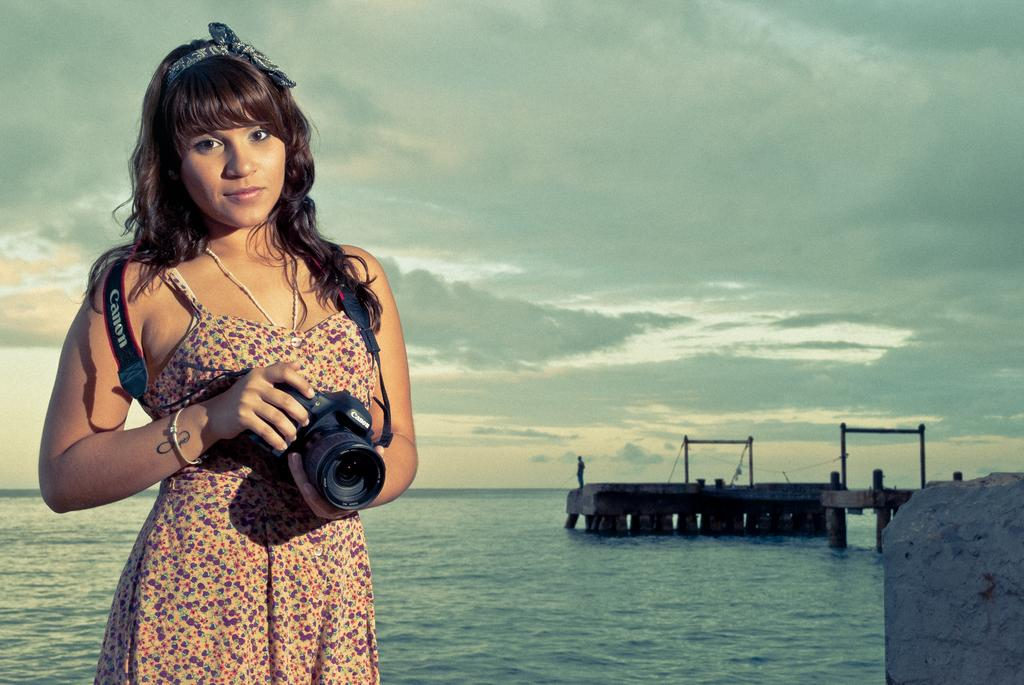Who is the main subject in the image? There is a lady in the image. What is the lady holding in the image? The lady is holding a Canon camera. What can be seen in the background of the image? There is a sea and stone hedges in the background of the image. Can you describe the activity of the guy in the image? The guy is on the stone hedge and is fishing. How many snails can be seen on the stone hedge in the image? There are no snails visible on the stone hedge in the image. What type of woman is present in the image? The image only features a lady, not a woman, and she is holding a Canon camera. 